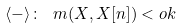<formula> <loc_0><loc_0><loc_500><loc_500>\langle - \rangle \colon \ m ( X , X [ n ] ) < o k</formula> 